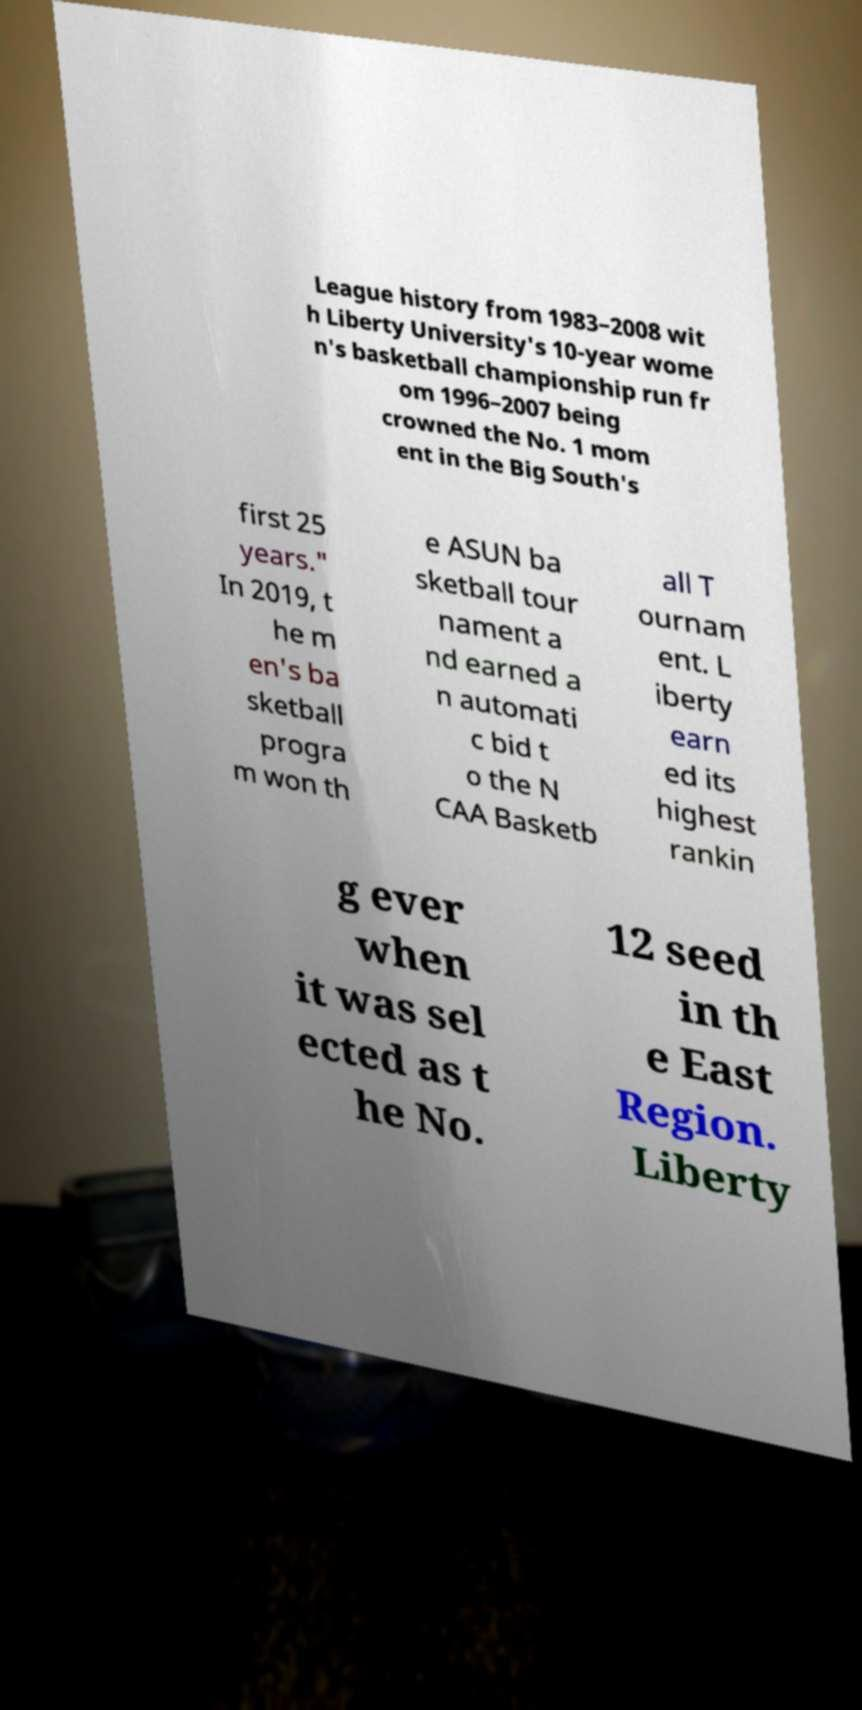For documentation purposes, I need the text within this image transcribed. Could you provide that? League history from 1983–2008 wit h Liberty University's 10-year wome n's basketball championship run fr om 1996–2007 being crowned the No. 1 mom ent in the Big South's first 25 years." In 2019, t he m en's ba sketball progra m won th e ASUN ba sketball tour nament a nd earned a n automati c bid t o the N CAA Basketb all T ournam ent. L iberty earn ed its highest rankin g ever when it was sel ected as t he No. 12 seed in th e East Region. Liberty 